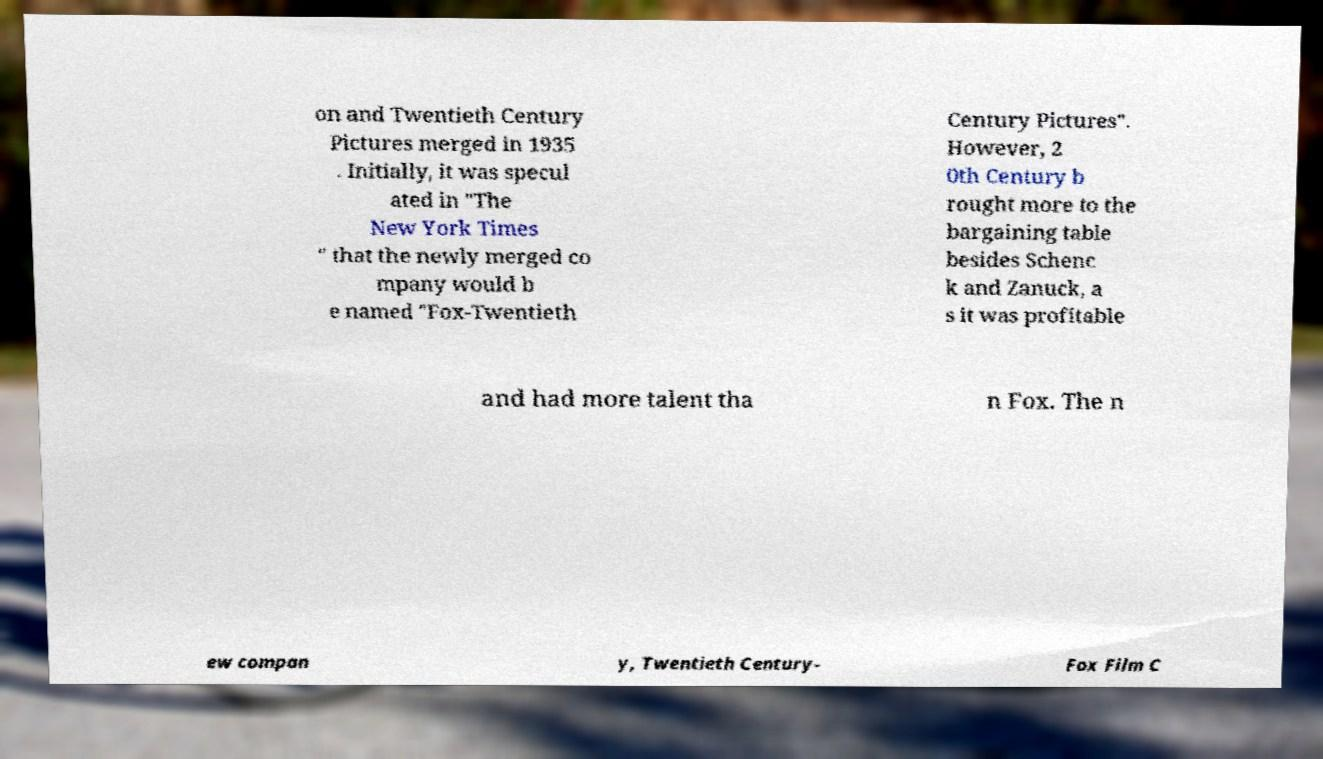There's text embedded in this image that I need extracted. Can you transcribe it verbatim? on and Twentieth Century Pictures merged in 1935 . Initially, it was specul ated in "The New York Times " that the newly merged co mpany would b e named "Fox-Twentieth Century Pictures". However, 2 0th Century b rought more to the bargaining table besides Schenc k and Zanuck, a s it was profitable and had more talent tha n Fox. The n ew compan y, Twentieth Century- Fox Film C 